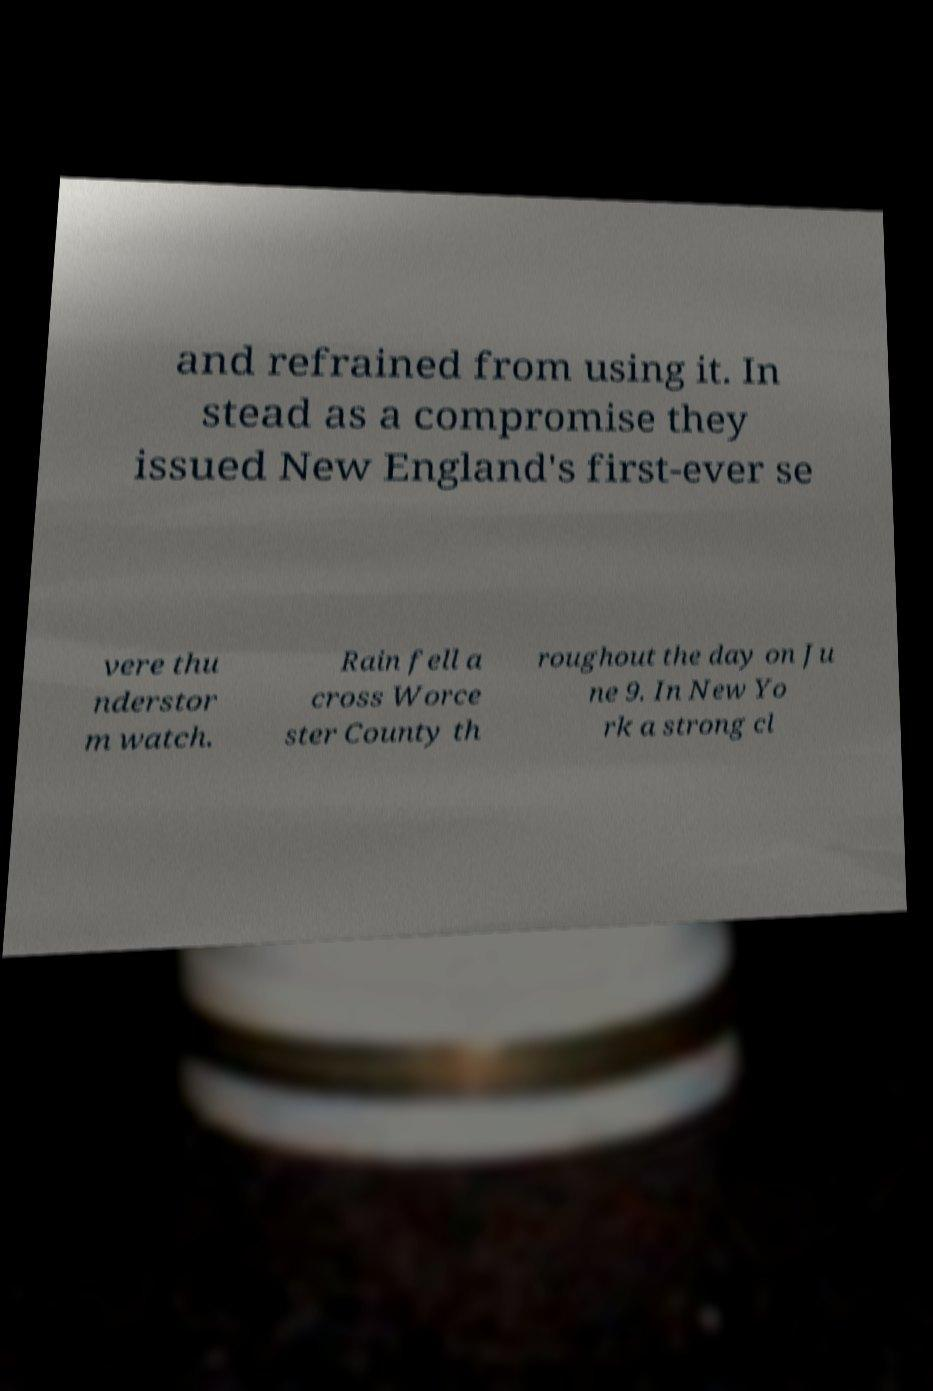Could you assist in decoding the text presented in this image and type it out clearly? and refrained from using it. In stead as a compromise they issued New England's first-ever se vere thu nderstor m watch. Rain fell a cross Worce ster County th roughout the day on Ju ne 9. In New Yo rk a strong cl 